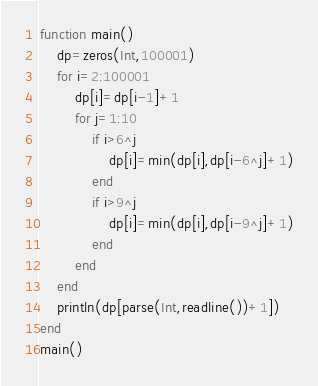Convert code to text. <code><loc_0><loc_0><loc_500><loc_500><_Julia_>function main()
	dp=zeros(Int,100001)
	for i=2:100001
		dp[i]=dp[i-1]+1
		for j=1:10
			if i>6^j
				dp[i]=min(dp[i],dp[i-6^j]+1)
			end
			if i>9^j
				dp[i]=min(dp[i],dp[i-9^j]+1)
			end
		end
	end
	println(dp[parse(Int,readline())+1])
end
main()
</code> 